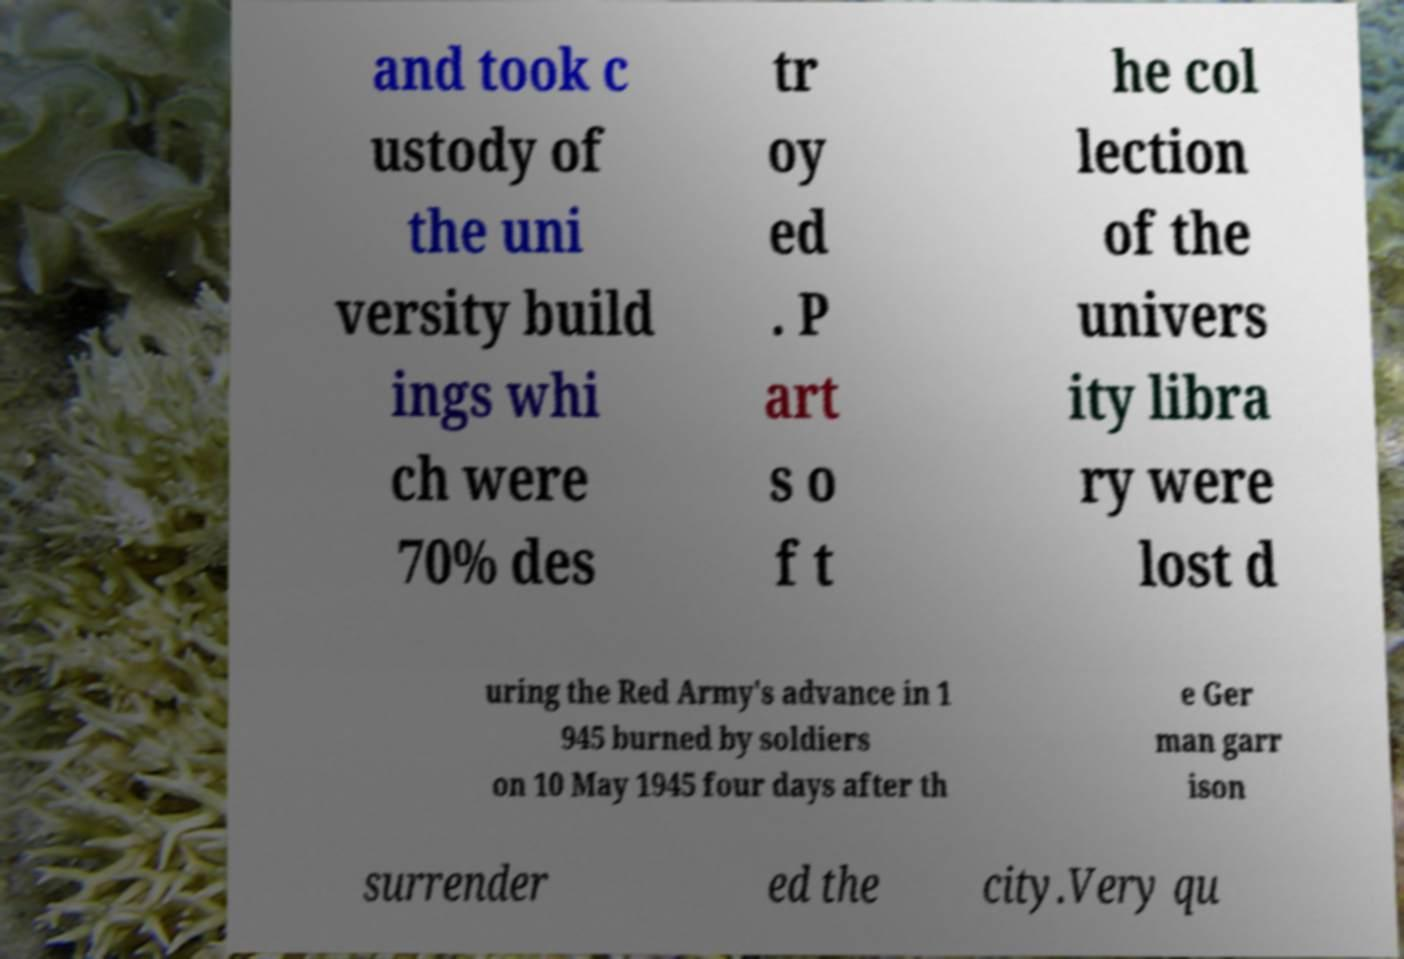I need the written content from this picture converted into text. Can you do that? and took c ustody of the uni versity build ings whi ch were 70% des tr oy ed . P art s o f t he col lection of the univers ity libra ry were lost d uring the Red Army's advance in 1 945 burned by soldiers on 10 May 1945 four days after th e Ger man garr ison surrender ed the city.Very qu 